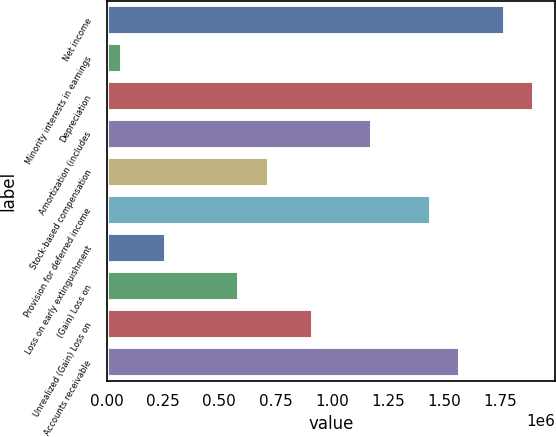Convert chart. <chart><loc_0><loc_0><loc_500><loc_500><bar_chart><fcel>Net income<fcel>Minority interests in earnings<fcel>Depreciation<fcel>Amortization (includes<fcel>Stock-based compensation<fcel>Provision for deferred income<fcel>Loss on early extinguishment<fcel>(Gain) Loss on<fcel>Unrealized (Gain) Loss on<fcel>Accounts receivable<nl><fcel>1.76772e+06<fcel>65853.3<fcel>1.89863e+06<fcel>1.17861e+06<fcel>720416<fcel>1.44044e+06<fcel>262222<fcel>589504<fcel>916785<fcel>1.57135e+06<nl></chart> 